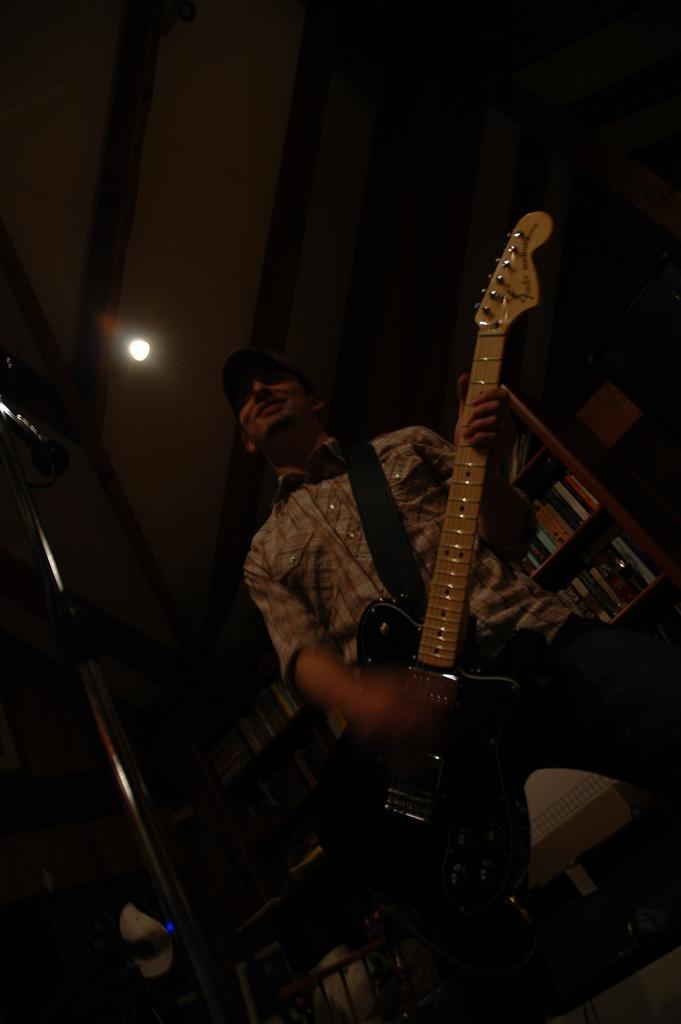Could you give a brief overview of what you see in this image? This is a picture taken in a room. It is dark. There is a man who is holding guitar. Background of this man there is shelf on the shelf there are books and a roof top with a light. 